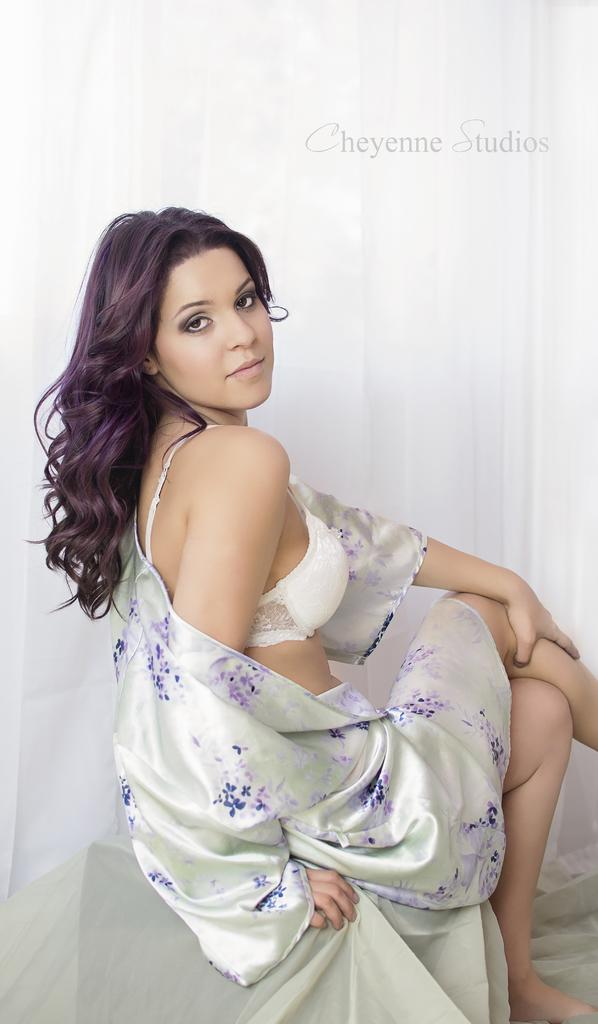What is the woman in the image doing? The woman is sitting in the image. What is the woman wearing? The woman is wearing a white dress. What is the color of the background in the image? The background in the image is white. Can you describe any additional features of the image? There is a watermark present in the image. How does the woman wash her hands in the image? There is no indication in the image that the woman is washing her hands, and no visible sink or water source is present. 